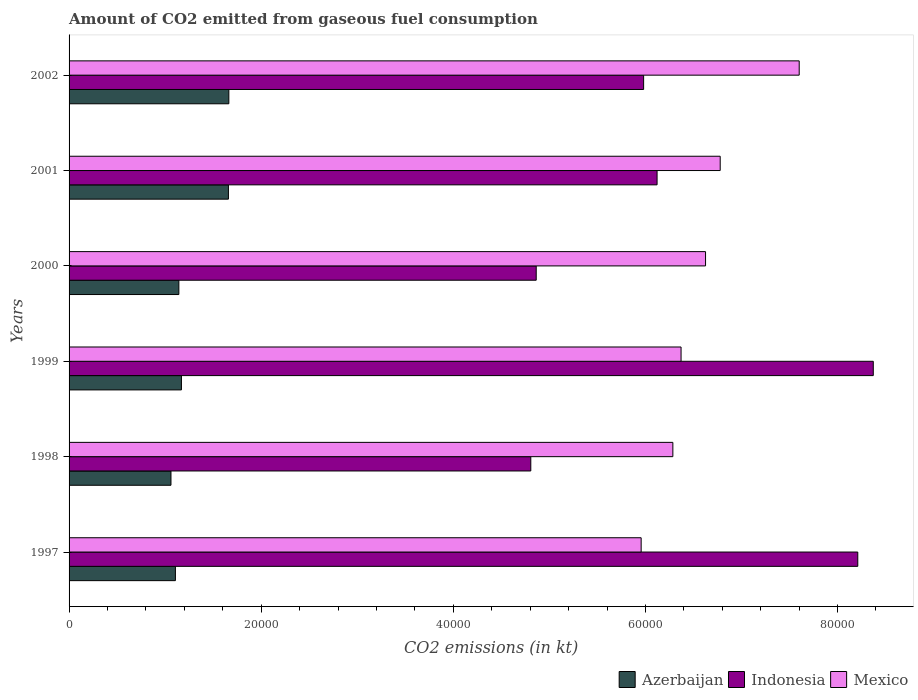How many different coloured bars are there?
Make the answer very short. 3. How many bars are there on the 2nd tick from the bottom?
Keep it short and to the point. 3. What is the label of the 1st group of bars from the top?
Ensure brevity in your answer.  2002. What is the amount of CO2 emitted in Azerbaijan in 1999?
Provide a succinct answer. 1.17e+04. Across all years, what is the maximum amount of CO2 emitted in Indonesia?
Give a very brief answer. 8.37e+04. Across all years, what is the minimum amount of CO2 emitted in Indonesia?
Your answer should be compact. 4.81e+04. In which year was the amount of CO2 emitted in Mexico minimum?
Offer a very short reply. 1997. What is the total amount of CO2 emitted in Indonesia in the graph?
Provide a short and direct response. 3.84e+05. What is the difference between the amount of CO2 emitted in Indonesia in 1998 and that in 2001?
Offer a terse response. -1.31e+04. What is the difference between the amount of CO2 emitted in Mexico in 1997 and the amount of CO2 emitted in Indonesia in 1999?
Your answer should be compact. -2.42e+04. What is the average amount of CO2 emitted in Mexico per year?
Keep it short and to the point. 6.60e+04. In the year 2000, what is the difference between the amount of CO2 emitted in Azerbaijan and amount of CO2 emitted in Mexico?
Your response must be concise. -5.48e+04. What is the ratio of the amount of CO2 emitted in Mexico in 2001 to that in 2002?
Your answer should be very brief. 0.89. Is the amount of CO2 emitted in Azerbaijan in 1998 less than that in 1999?
Offer a very short reply. Yes. What is the difference between the highest and the second highest amount of CO2 emitted in Mexico?
Your response must be concise. 8225.08. What is the difference between the highest and the lowest amount of CO2 emitted in Mexico?
Provide a succinct answer. 1.65e+04. In how many years, is the amount of CO2 emitted in Indonesia greater than the average amount of CO2 emitted in Indonesia taken over all years?
Give a very brief answer. 2. What does the 3rd bar from the top in 2000 represents?
Your answer should be very brief. Azerbaijan. What does the 1st bar from the bottom in 1998 represents?
Give a very brief answer. Azerbaijan. How many bars are there?
Your answer should be very brief. 18. Are all the bars in the graph horizontal?
Your response must be concise. Yes. What is the difference between two consecutive major ticks on the X-axis?
Provide a succinct answer. 2.00e+04. Are the values on the major ticks of X-axis written in scientific E-notation?
Provide a succinct answer. No. Does the graph contain grids?
Your response must be concise. No. What is the title of the graph?
Give a very brief answer. Amount of CO2 emitted from gaseous fuel consumption. What is the label or title of the X-axis?
Your answer should be compact. CO2 emissions (in kt). What is the label or title of the Y-axis?
Offer a very short reply. Years. What is the CO2 emissions (in kt) of Azerbaijan in 1997?
Offer a very short reply. 1.11e+04. What is the CO2 emissions (in kt) of Indonesia in 1997?
Your answer should be very brief. 8.21e+04. What is the CO2 emissions (in kt) of Mexico in 1997?
Make the answer very short. 5.96e+04. What is the CO2 emissions (in kt) in Azerbaijan in 1998?
Your answer should be very brief. 1.06e+04. What is the CO2 emissions (in kt) in Indonesia in 1998?
Make the answer very short. 4.81e+04. What is the CO2 emissions (in kt) of Mexico in 1998?
Provide a succinct answer. 6.29e+04. What is the CO2 emissions (in kt) of Azerbaijan in 1999?
Give a very brief answer. 1.17e+04. What is the CO2 emissions (in kt) of Indonesia in 1999?
Your response must be concise. 8.37e+04. What is the CO2 emissions (in kt) of Mexico in 1999?
Provide a short and direct response. 6.37e+04. What is the CO2 emissions (in kt) of Azerbaijan in 2000?
Keep it short and to the point. 1.14e+04. What is the CO2 emissions (in kt) in Indonesia in 2000?
Give a very brief answer. 4.86e+04. What is the CO2 emissions (in kt) in Mexico in 2000?
Make the answer very short. 6.63e+04. What is the CO2 emissions (in kt) in Azerbaijan in 2001?
Offer a terse response. 1.66e+04. What is the CO2 emissions (in kt) of Indonesia in 2001?
Make the answer very short. 6.12e+04. What is the CO2 emissions (in kt) in Mexico in 2001?
Your answer should be compact. 6.78e+04. What is the CO2 emissions (in kt) in Azerbaijan in 2002?
Offer a terse response. 1.66e+04. What is the CO2 emissions (in kt) of Indonesia in 2002?
Your response must be concise. 5.98e+04. What is the CO2 emissions (in kt) of Mexico in 2002?
Offer a terse response. 7.60e+04. Across all years, what is the maximum CO2 emissions (in kt) in Azerbaijan?
Provide a succinct answer. 1.66e+04. Across all years, what is the maximum CO2 emissions (in kt) of Indonesia?
Keep it short and to the point. 8.37e+04. Across all years, what is the maximum CO2 emissions (in kt) in Mexico?
Give a very brief answer. 7.60e+04. Across all years, what is the minimum CO2 emissions (in kt) of Azerbaijan?
Your answer should be compact. 1.06e+04. Across all years, what is the minimum CO2 emissions (in kt) in Indonesia?
Make the answer very short. 4.81e+04. Across all years, what is the minimum CO2 emissions (in kt) in Mexico?
Your answer should be compact. 5.96e+04. What is the total CO2 emissions (in kt) in Azerbaijan in the graph?
Your answer should be very brief. 7.80e+04. What is the total CO2 emissions (in kt) of Indonesia in the graph?
Your answer should be compact. 3.84e+05. What is the total CO2 emissions (in kt) in Mexico in the graph?
Give a very brief answer. 3.96e+05. What is the difference between the CO2 emissions (in kt) of Azerbaijan in 1997 and that in 1998?
Provide a short and direct response. 462.04. What is the difference between the CO2 emissions (in kt) in Indonesia in 1997 and that in 1998?
Your response must be concise. 3.40e+04. What is the difference between the CO2 emissions (in kt) in Mexico in 1997 and that in 1998?
Provide a short and direct response. -3300.3. What is the difference between the CO2 emissions (in kt) in Azerbaijan in 1997 and that in 1999?
Your answer should be very brief. -627.06. What is the difference between the CO2 emissions (in kt) of Indonesia in 1997 and that in 1999?
Offer a very short reply. -1613.48. What is the difference between the CO2 emissions (in kt) of Mexico in 1997 and that in 1999?
Offer a terse response. -4154.71. What is the difference between the CO2 emissions (in kt) in Azerbaijan in 1997 and that in 2000?
Provide a succinct answer. -359.37. What is the difference between the CO2 emissions (in kt) of Indonesia in 1997 and that in 2000?
Your answer should be very brief. 3.35e+04. What is the difference between the CO2 emissions (in kt) of Mexico in 1997 and that in 2000?
Give a very brief answer. -6703.28. What is the difference between the CO2 emissions (in kt) in Azerbaijan in 1997 and that in 2001?
Make the answer very short. -5518.84. What is the difference between the CO2 emissions (in kt) of Indonesia in 1997 and that in 2001?
Your response must be concise. 2.09e+04. What is the difference between the CO2 emissions (in kt) of Mexico in 1997 and that in 2001?
Make the answer very short. -8228.75. What is the difference between the CO2 emissions (in kt) of Azerbaijan in 1997 and that in 2002?
Your response must be concise. -5562.84. What is the difference between the CO2 emissions (in kt) in Indonesia in 1997 and that in 2002?
Keep it short and to the point. 2.23e+04. What is the difference between the CO2 emissions (in kt) in Mexico in 1997 and that in 2002?
Give a very brief answer. -1.65e+04. What is the difference between the CO2 emissions (in kt) in Azerbaijan in 1998 and that in 1999?
Keep it short and to the point. -1089.1. What is the difference between the CO2 emissions (in kt) in Indonesia in 1998 and that in 1999?
Your response must be concise. -3.57e+04. What is the difference between the CO2 emissions (in kt) in Mexico in 1998 and that in 1999?
Make the answer very short. -854.41. What is the difference between the CO2 emissions (in kt) of Azerbaijan in 1998 and that in 2000?
Ensure brevity in your answer.  -821.41. What is the difference between the CO2 emissions (in kt) in Indonesia in 1998 and that in 2000?
Your response must be concise. -564.72. What is the difference between the CO2 emissions (in kt) of Mexico in 1998 and that in 2000?
Offer a terse response. -3402.98. What is the difference between the CO2 emissions (in kt) in Azerbaijan in 1998 and that in 2001?
Provide a succinct answer. -5980.88. What is the difference between the CO2 emissions (in kt) in Indonesia in 1998 and that in 2001?
Provide a short and direct response. -1.31e+04. What is the difference between the CO2 emissions (in kt) of Mexico in 1998 and that in 2001?
Offer a terse response. -4928.45. What is the difference between the CO2 emissions (in kt) of Azerbaijan in 1998 and that in 2002?
Make the answer very short. -6024.88. What is the difference between the CO2 emissions (in kt) of Indonesia in 1998 and that in 2002?
Your answer should be compact. -1.17e+04. What is the difference between the CO2 emissions (in kt) of Mexico in 1998 and that in 2002?
Ensure brevity in your answer.  -1.32e+04. What is the difference between the CO2 emissions (in kt) in Azerbaijan in 1999 and that in 2000?
Provide a succinct answer. 267.69. What is the difference between the CO2 emissions (in kt) in Indonesia in 1999 and that in 2000?
Offer a terse response. 3.51e+04. What is the difference between the CO2 emissions (in kt) of Mexico in 1999 and that in 2000?
Offer a terse response. -2548.57. What is the difference between the CO2 emissions (in kt) of Azerbaijan in 1999 and that in 2001?
Give a very brief answer. -4891.78. What is the difference between the CO2 emissions (in kt) in Indonesia in 1999 and that in 2001?
Ensure brevity in your answer.  2.25e+04. What is the difference between the CO2 emissions (in kt) in Mexico in 1999 and that in 2001?
Give a very brief answer. -4074.04. What is the difference between the CO2 emissions (in kt) in Azerbaijan in 1999 and that in 2002?
Offer a terse response. -4935.78. What is the difference between the CO2 emissions (in kt) of Indonesia in 1999 and that in 2002?
Your answer should be very brief. 2.39e+04. What is the difference between the CO2 emissions (in kt) in Mexico in 1999 and that in 2002?
Give a very brief answer. -1.23e+04. What is the difference between the CO2 emissions (in kt) of Azerbaijan in 2000 and that in 2001?
Provide a short and direct response. -5159.47. What is the difference between the CO2 emissions (in kt) of Indonesia in 2000 and that in 2001?
Your answer should be compact. -1.26e+04. What is the difference between the CO2 emissions (in kt) in Mexico in 2000 and that in 2001?
Offer a terse response. -1525.47. What is the difference between the CO2 emissions (in kt) of Azerbaijan in 2000 and that in 2002?
Offer a terse response. -5203.47. What is the difference between the CO2 emissions (in kt) of Indonesia in 2000 and that in 2002?
Your answer should be compact. -1.12e+04. What is the difference between the CO2 emissions (in kt) in Mexico in 2000 and that in 2002?
Provide a succinct answer. -9750.55. What is the difference between the CO2 emissions (in kt) of Azerbaijan in 2001 and that in 2002?
Your answer should be very brief. -44. What is the difference between the CO2 emissions (in kt) in Indonesia in 2001 and that in 2002?
Make the answer very short. 1400.79. What is the difference between the CO2 emissions (in kt) in Mexico in 2001 and that in 2002?
Provide a succinct answer. -8225.08. What is the difference between the CO2 emissions (in kt) in Azerbaijan in 1997 and the CO2 emissions (in kt) in Indonesia in 1998?
Provide a short and direct response. -3.70e+04. What is the difference between the CO2 emissions (in kt) in Azerbaijan in 1997 and the CO2 emissions (in kt) in Mexico in 1998?
Give a very brief answer. -5.18e+04. What is the difference between the CO2 emissions (in kt) in Indonesia in 1997 and the CO2 emissions (in kt) in Mexico in 1998?
Give a very brief answer. 1.93e+04. What is the difference between the CO2 emissions (in kt) of Azerbaijan in 1997 and the CO2 emissions (in kt) of Indonesia in 1999?
Your response must be concise. -7.27e+04. What is the difference between the CO2 emissions (in kt) in Azerbaijan in 1997 and the CO2 emissions (in kt) in Mexico in 1999?
Provide a short and direct response. -5.26e+04. What is the difference between the CO2 emissions (in kt) of Indonesia in 1997 and the CO2 emissions (in kt) of Mexico in 1999?
Your response must be concise. 1.84e+04. What is the difference between the CO2 emissions (in kt) of Azerbaijan in 1997 and the CO2 emissions (in kt) of Indonesia in 2000?
Offer a terse response. -3.76e+04. What is the difference between the CO2 emissions (in kt) in Azerbaijan in 1997 and the CO2 emissions (in kt) in Mexico in 2000?
Your response must be concise. -5.52e+04. What is the difference between the CO2 emissions (in kt) in Indonesia in 1997 and the CO2 emissions (in kt) in Mexico in 2000?
Your answer should be very brief. 1.58e+04. What is the difference between the CO2 emissions (in kt) of Azerbaijan in 1997 and the CO2 emissions (in kt) of Indonesia in 2001?
Keep it short and to the point. -5.01e+04. What is the difference between the CO2 emissions (in kt) of Azerbaijan in 1997 and the CO2 emissions (in kt) of Mexico in 2001?
Your answer should be compact. -5.67e+04. What is the difference between the CO2 emissions (in kt) in Indonesia in 1997 and the CO2 emissions (in kt) in Mexico in 2001?
Make the answer very short. 1.43e+04. What is the difference between the CO2 emissions (in kt) of Azerbaijan in 1997 and the CO2 emissions (in kt) of Indonesia in 2002?
Keep it short and to the point. -4.87e+04. What is the difference between the CO2 emissions (in kt) of Azerbaijan in 1997 and the CO2 emissions (in kt) of Mexico in 2002?
Give a very brief answer. -6.49e+04. What is the difference between the CO2 emissions (in kt) in Indonesia in 1997 and the CO2 emissions (in kt) in Mexico in 2002?
Provide a short and direct response. 6098.22. What is the difference between the CO2 emissions (in kt) in Azerbaijan in 1998 and the CO2 emissions (in kt) in Indonesia in 1999?
Keep it short and to the point. -7.31e+04. What is the difference between the CO2 emissions (in kt) in Azerbaijan in 1998 and the CO2 emissions (in kt) in Mexico in 1999?
Your response must be concise. -5.31e+04. What is the difference between the CO2 emissions (in kt) in Indonesia in 1998 and the CO2 emissions (in kt) in Mexico in 1999?
Make the answer very short. -1.56e+04. What is the difference between the CO2 emissions (in kt) in Azerbaijan in 1998 and the CO2 emissions (in kt) in Indonesia in 2000?
Keep it short and to the point. -3.80e+04. What is the difference between the CO2 emissions (in kt) in Azerbaijan in 1998 and the CO2 emissions (in kt) in Mexico in 2000?
Your answer should be compact. -5.57e+04. What is the difference between the CO2 emissions (in kt) of Indonesia in 1998 and the CO2 emissions (in kt) of Mexico in 2000?
Offer a terse response. -1.82e+04. What is the difference between the CO2 emissions (in kt) in Azerbaijan in 1998 and the CO2 emissions (in kt) in Indonesia in 2001?
Offer a very short reply. -5.06e+04. What is the difference between the CO2 emissions (in kt) in Azerbaijan in 1998 and the CO2 emissions (in kt) in Mexico in 2001?
Provide a short and direct response. -5.72e+04. What is the difference between the CO2 emissions (in kt) in Indonesia in 1998 and the CO2 emissions (in kt) in Mexico in 2001?
Your answer should be very brief. -1.97e+04. What is the difference between the CO2 emissions (in kt) of Azerbaijan in 1998 and the CO2 emissions (in kt) of Indonesia in 2002?
Offer a terse response. -4.92e+04. What is the difference between the CO2 emissions (in kt) of Azerbaijan in 1998 and the CO2 emissions (in kt) of Mexico in 2002?
Your answer should be compact. -6.54e+04. What is the difference between the CO2 emissions (in kt) in Indonesia in 1998 and the CO2 emissions (in kt) in Mexico in 2002?
Your answer should be very brief. -2.79e+04. What is the difference between the CO2 emissions (in kt) of Azerbaijan in 1999 and the CO2 emissions (in kt) of Indonesia in 2000?
Your response must be concise. -3.69e+04. What is the difference between the CO2 emissions (in kt) in Azerbaijan in 1999 and the CO2 emissions (in kt) in Mexico in 2000?
Offer a very short reply. -5.46e+04. What is the difference between the CO2 emissions (in kt) of Indonesia in 1999 and the CO2 emissions (in kt) of Mexico in 2000?
Provide a short and direct response. 1.75e+04. What is the difference between the CO2 emissions (in kt) in Azerbaijan in 1999 and the CO2 emissions (in kt) in Indonesia in 2001?
Give a very brief answer. -4.95e+04. What is the difference between the CO2 emissions (in kt) in Azerbaijan in 1999 and the CO2 emissions (in kt) in Mexico in 2001?
Make the answer very short. -5.61e+04. What is the difference between the CO2 emissions (in kt) in Indonesia in 1999 and the CO2 emissions (in kt) in Mexico in 2001?
Give a very brief answer. 1.59e+04. What is the difference between the CO2 emissions (in kt) in Azerbaijan in 1999 and the CO2 emissions (in kt) in Indonesia in 2002?
Ensure brevity in your answer.  -4.81e+04. What is the difference between the CO2 emissions (in kt) in Azerbaijan in 1999 and the CO2 emissions (in kt) in Mexico in 2002?
Provide a short and direct response. -6.43e+04. What is the difference between the CO2 emissions (in kt) in Indonesia in 1999 and the CO2 emissions (in kt) in Mexico in 2002?
Keep it short and to the point. 7711.7. What is the difference between the CO2 emissions (in kt) in Azerbaijan in 2000 and the CO2 emissions (in kt) in Indonesia in 2001?
Make the answer very short. -4.98e+04. What is the difference between the CO2 emissions (in kt) in Azerbaijan in 2000 and the CO2 emissions (in kt) in Mexico in 2001?
Provide a succinct answer. -5.64e+04. What is the difference between the CO2 emissions (in kt) of Indonesia in 2000 and the CO2 emissions (in kt) of Mexico in 2001?
Your answer should be compact. -1.92e+04. What is the difference between the CO2 emissions (in kt) of Azerbaijan in 2000 and the CO2 emissions (in kt) of Indonesia in 2002?
Make the answer very short. -4.84e+04. What is the difference between the CO2 emissions (in kt) of Azerbaijan in 2000 and the CO2 emissions (in kt) of Mexico in 2002?
Ensure brevity in your answer.  -6.46e+04. What is the difference between the CO2 emissions (in kt) of Indonesia in 2000 and the CO2 emissions (in kt) of Mexico in 2002?
Your answer should be compact. -2.74e+04. What is the difference between the CO2 emissions (in kt) of Azerbaijan in 2001 and the CO2 emissions (in kt) of Indonesia in 2002?
Give a very brief answer. -4.32e+04. What is the difference between the CO2 emissions (in kt) of Azerbaijan in 2001 and the CO2 emissions (in kt) of Mexico in 2002?
Your answer should be compact. -5.94e+04. What is the difference between the CO2 emissions (in kt) of Indonesia in 2001 and the CO2 emissions (in kt) of Mexico in 2002?
Offer a very short reply. -1.48e+04. What is the average CO2 emissions (in kt) in Azerbaijan per year?
Give a very brief answer. 1.30e+04. What is the average CO2 emissions (in kt) of Indonesia per year?
Provide a short and direct response. 6.39e+04. What is the average CO2 emissions (in kt) of Mexico per year?
Your answer should be very brief. 6.60e+04. In the year 1997, what is the difference between the CO2 emissions (in kt) in Azerbaijan and CO2 emissions (in kt) in Indonesia?
Make the answer very short. -7.10e+04. In the year 1997, what is the difference between the CO2 emissions (in kt) in Azerbaijan and CO2 emissions (in kt) in Mexico?
Make the answer very short. -4.85e+04. In the year 1997, what is the difference between the CO2 emissions (in kt) of Indonesia and CO2 emissions (in kt) of Mexico?
Your answer should be very brief. 2.26e+04. In the year 1998, what is the difference between the CO2 emissions (in kt) of Azerbaijan and CO2 emissions (in kt) of Indonesia?
Keep it short and to the point. -3.75e+04. In the year 1998, what is the difference between the CO2 emissions (in kt) of Azerbaijan and CO2 emissions (in kt) of Mexico?
Offer a terse response. -5.22e+04. In the year 1998, what is the difference between the CO2 emissions (in kt) of Indonesia and CO2 emissions (in kt) of Mexico?
Offer a very short reply. -1.48e+04. In the year 1999, what is the difference between the CO2 emissions (in kt) of Azerbaijan and CO2 emissions (in kt) of Indonesia?
Your answer should be very brief. -7.20e+04. In the year 1999, what is the difference between the CO2 emissions (in kt) in Azerbaijan and CO2 emissions (in kt) in Mexico?
Give a very brief answer. -5.20e+04. In the year 1999, what is the difference between the CO2 emissions (in kt) in Indonesia and CO2 emissions (in kt) in Mexico?
Make the answer very short. 2.00e+04. In the year 2000, what is the difference between the CO2 emissions (in kt) of Azerbaijan and CO2 emissions (in kt) of Indonesia?
Offer a very short reply. -3.72e+04. In the year 2000, what is the difference between the CO2 emissions (in kt) of Azerbaijan and CO2 emissions (in kt) of Mexico?
Offer a very short reply. -5.48e+04. In the year 2000, what is the difference between the CO2 emissions (in kt) in Indonesia and CO2 emissions (in kt) in Mexico?
Offer a terse response. -1.76e+04. In the year 2001, what is the difference between the CO2 emissions (in kt) in Azerbaijan and CO2 emissions (in kt) in Indonesia?
Offer a terse response. -4.46e+04. In the year 2001, what is the difference between the CO2 emissions (in kt) of Azerbaijan and CO2 emissions (in kt) of Mexico?
Provide a succinct answer. -5.12e+04. In the year 2001, what is the difference between the CO2 emissions (in kt) of Indonesia and CO2 emissions (in kt) of Mexico?
Ensure brevity in your answer.  -6571.26. In the year 2002, what is the difference between the CO2 emissions (in kt) in Azerbaijan and CO2 emissions (in kt) in Indonesia?
Provide a short and direct response. -4.32e+04. In the year 2002, what is the difference between the CO2 emissions (in kt) of Azerbaijan and CO2 emissions (in kt) of Mexico?
Your answer should be very brief. -5.94e+04. In the year 2002, what is the difference between the CO2 emissions (in kt) of Indonesia and CO2 emissions (in kt) of Mexico?
Your answer should be very brief. -1.62e+04. What is the ratio of the CO2 emissions (in kt) in Azerbaijan in 1997 to that in 1998?
Ensure brevity in your answer.  1.04. What is the ratio of the CO2 emissions (in kt) of Indonesia in 1997 to that in 1998?
Give a very brief answer. 1.71. What is the ratio of the CO2 emissions (in kt) in Mexico in 1997 to that in 1998?
Ensure brevity in your answer.  0.95. What is the ratio of the CO2 emissions (in kt) in Azerbaijan in 1997 to that in 1999?
Keep it short and to the point. 0.95. What is the ratio of the CO2 emissions (in kt) in Indonesia in 1997 to that in 1999?
Provide a succinct answer. 0.98. What is the ratio of the CO2 emissions (in kt) of Mexico in 1997 to that in 1999?
Provide a short and direct response. 0.93. What is the ratio of the CO2 emissions (in kt) in Azerbaijan in 1997 to that in 2000?
Your answer should be very brief. 0.97. What is the ratio of the CO2 emissions (in kt) in Indonesia in 1997 to that in 2000?
Your answer should be compact. 1.69. What is the ratio of the CO2 emissions (in kt) in Mexico in 1997 to that in 2000?
Your answer should be very brief. 0.9. What is the ratio of the CO2 emissions (in kt) in Azerbaijan in 1997 to that in 2001?
Keep it short and to the point. 0.67. What is the ratio of the CO2 emissions (in kt) of Indonesia in 1997 to that in 2001?
Make the answer very short. 1.34. What is the ratio of the CO2 emissions (in kt) of Mexico in 1997 to that in 2001?
Provide a short and direct response. 0.88. What is the ratio of the CO2 emissions (in kt) of Azerbaijan in 1997 to that in 2002?
Ensure brevity in your answer.  0.67. What is the ratio of the CO2 emissions (in kt) of Indonesia in 1997 to that in 2002?
Your response must be concise. 1.37. What is the ratio of the CO2 emissions (in kt) in Mexico in 1997 to that in 2002?
Offer a very short reply. 0.78. What is the ratio of the CO2 emissions (in kt) in Azerbaijan in 1998 to that in 1999?
Make the answer very short. 0.91. What is the ratio of the CO2 emissions (in kt) in Indonesia in 1998 to that in 1999?
Keep it short and to the point. 0.57. What is the ratio of the CO2 emissions (in kt) of Mexico in 1998 to that in 1999?
Offer a very short reply. 0.99. What is the ratio of the CO2 emissions (in kt) in Azerbaijan in 1998 to that in 2000?
Provide a succinct answer. 0.93. What is the ratio of the CO2 emissions (in kt) in Indonesia in 1998 to that in 2000?
Offer a very short reply. 0.99. What is the ratio of the CO2 emissions (in kt) of Mexico in 1998 to that in 2000?
Keep it short and to the point. 0.95. What is the ratio of the CO2 emissions (in kt) of Azerbaijan in 1998 to that in 2001?
Your answer should be compact. 0.64. What is the ratio of the CO2 emissions (in kt) of Indonesia in 1998 to that in 2001?
Provide a short and direct response. 0.79. What is the ratio of the CO2 emissions (in kt) in Mexico in 1998 to that in 2001?
Your answer should be very brief. 0.93. What is the ratio of the CO2 emissions (in kt) in Azerbaijan in 1998 to that in 2002?
Ensure brevity in your answer.  0.64. What is the ratio of the CO2 emissions (in kt) of Indonesia in 1998 to that in 2002?
Offer a very short reply. 0.8. What is the ratio of the CO2 emissions (in kt) of Mexico in 1998 to that in 2002?
Give a very brief answer. 0.83. What is the ratio of the CO2 emissions (in kt) in Azerbaijan in 1999 to that in 2000?
Ensure brevity in your answer.  1.02. What is the ratio of the CO2 emissions (in kt) of Indonesia in 1999 to that in 2000?
Provide a succinct answer. 1.72. What is the ratio of the CO2 emissions (in kt) of Mexico in 1999 to that in 2000?
Your answer should be very brief. 0.96. What is the ratio of the CO2 emissions (in kt) of Azerbaijan in 1999 to that in 2001?
Give a very brief answer. 0.71. What is the ratio of the CO2 emissions (in kt) of Indonesia in 1999 to that in 2001?
Provide a succinct answer. 1.37. What is the ratio of the CO2 emissions (in kt) of Mexico in 1999 to that in 2001?
Keep it short and to the point. 0.94. What is the ratio of the CO2 emissions (in kt) in Azerbaijan in 1999 to that in 2002?
Offer a very short reply. 0.7. What is the ratio of the CO2 emissions (in kt) of Indonesia in 1999 to that in 2002?
Offer a very short reply. 1.4. What is the ratio of the CO2 emissions (in kt) of Mexico in 1999 to that in 2002?
Your response must be concise. 0.84. What is the ratio of the CO2 emissions (in kt) in Azerbaijan in 2000 to that in 2001?
Ensure brevity in your answer.  0.69. What is the ratio of the CO2 emissions (in kt) of Indonesia in 2000 to that in 2001?
Make the answer very short. 0.79. What is the ratio of the CO2 emissions (in kt) in Mexico in 2000 to that in 2001?
Make the answer very short. 0.98. What is the ratio of the CO2 emissions (in kt) of Azerbaijan in 2000 to that in 2002?
Offer a terse response. 0.69. What is the ratio of the CO2 emissions (in kt) in Indonesia in 2000 to that in 2002?
Offer a terse response. 0.81. What is the ratio of the CO2 emissions (in kt) of Mexico in 2000 to that in 2002?
Give a very brief answer. 0.87. What is the ratio of the CO2 emissions (in kt) of Indonesia in 2001 to that in 2002?
Your answer should be very brief. 1.02. What is the ratio of the CO2 emissions (in kt) of Mexico in 2001 to that in 2002?
Your response must be concise. 0.89. What is the difference between the highest and the second highest CO2 emissions (in kt) in Azerbaijan?
Offer a terse response. 44. What is the difference between the highest and the second highest CO2 emissions (in kt) of Indonesia?
Offer a terse response. 1613.48. What is the difference between the highest and the second highest CO2 emissions (in kt) in Mexico?
Your answer should be compact. 8225.08. What is the difference between the highest and the lowest CO2 emissions (in kt) in Azerbaijan?
Make the answer very short. 6024.88. What is the difference between the highest and the lowest CO2 emissions (in kt) of Indonesia?
Keep it short and to the point. 3.57e+04. What is the difference between the highest and the lowest CO2 emissions (in kt) of Mexico?
Provide a short and direct response. 1.65e+04. 